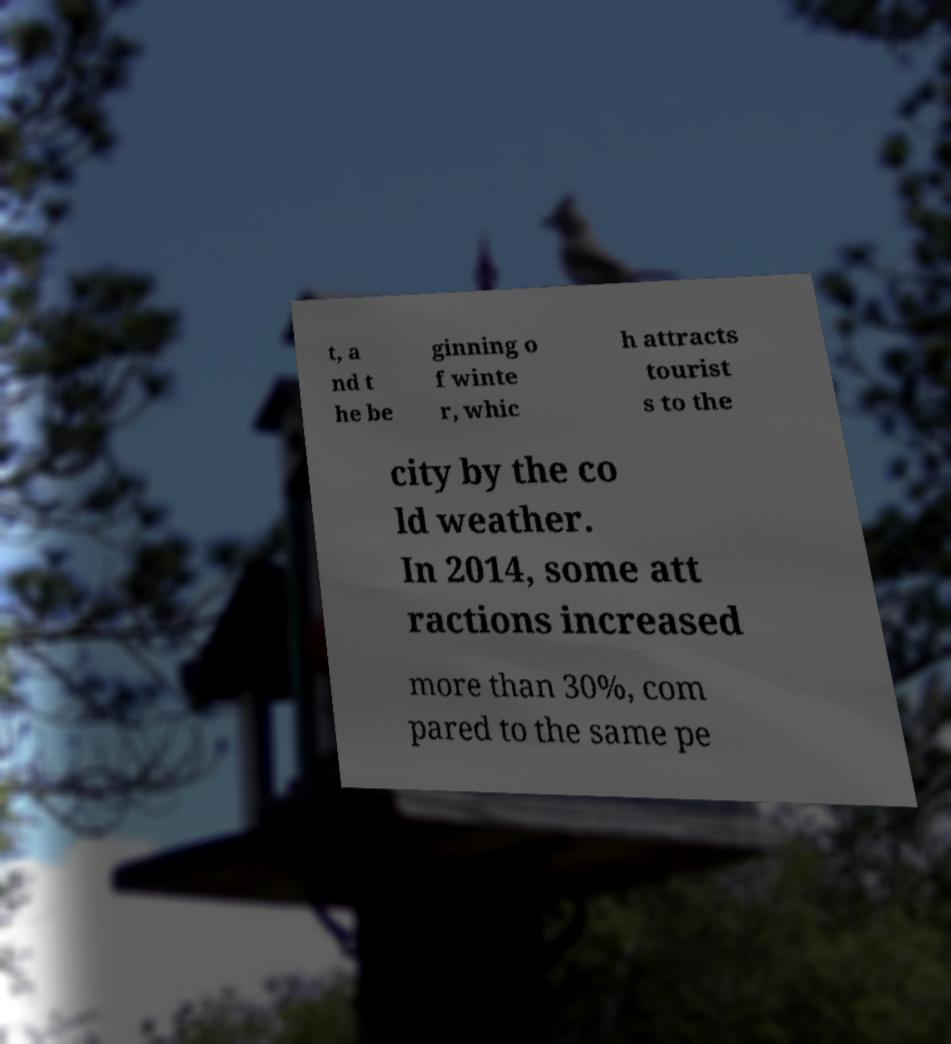I need the written content from this picture converted into text. Can you do that? t, a nd t he be ginning o f winte r, whic h attracts tourist s to the city by the co ld weather. In 2014, some att ractions increased more than 30%, com pared to the same pe 